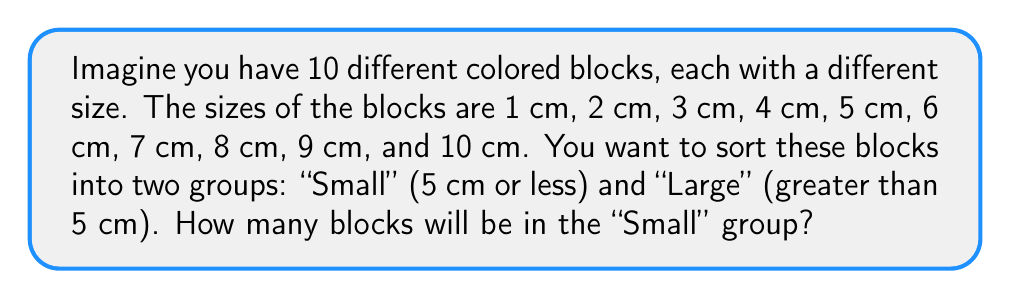Can you solve this math problem? Let's approach this step-by-step:

1. First, we need to identify which blocks are 5 cm or less:
   - 1 cm block: Small
   - 2 cm block: Small
   - 3 cm block: Small
   - 4 cm block: Small
   - 5 cm block: Small

2. Now, let's count how many blocks we identified as "Small":
   $$ \text{Number of Small blocks} = 1 + 1 + 1 + 1 + 1 = 5 $$

3. We can verify this by counting the blocks larger than 5 cm:
   - 6 cm, 7 cm, 8 cm, 9 cm, and 10 cm blocks are all larger than 5 cm.
   - There are 5 blocks larger than 5 cm.
   - Since there are 10 blocks in total, and 5 are larger than 5 cm, this confirms that 5 blocks are 5 cm or less.

Therefore, there will be 5 blocks in the "Small" group.
Answer: 5 blocks 